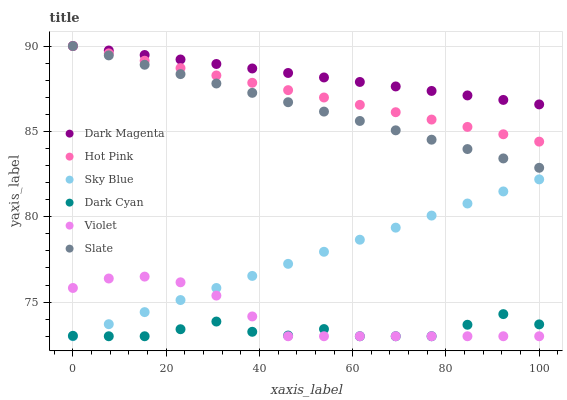Does Dark Cyan have the minimum area under the curve?
Answer yes or no. Yes. Does Dark Magenta have the maximum area under the curve?
Answer yes or no. Yes. Does Slate have the minimum area under the curve?
Answer yes or no. No. Does Slate have the maximum area under the curve?
Answer yes or no. No. Is Sky Blue the smoothest?
Answer yes or no. Yes. Is Dark Cyan the roughest?
Answer yes or no. Yes. Is Slate the smoothest?
Answer yes or no. No. Is Slate the roughest?
Answer yes or no. No. Does Violet have the lowest value?
Answer yes or no. Yes. Does Slate have the lowest value?
Answer yes or no. No. Does Hot Pink have the highest value?
Answer yes or no. Yes. Does Violet have the highest value?
Answer yes or no. No. Is Violet less than Dark Magenta?
Answer yes or no. Yes. Is Slate greater than Dark Cyan?
Answer yes or no. Yes. Does Sky Blue intersect Violet?
Answer yes or no. Yes. Is Sky Blue less than Violet?
Answer yes or no. No. Is Sky Blue greater than Violet?
Answer yes or no. No. Does Violet intersect Dark Magenta?
Answer yes or no. No. 